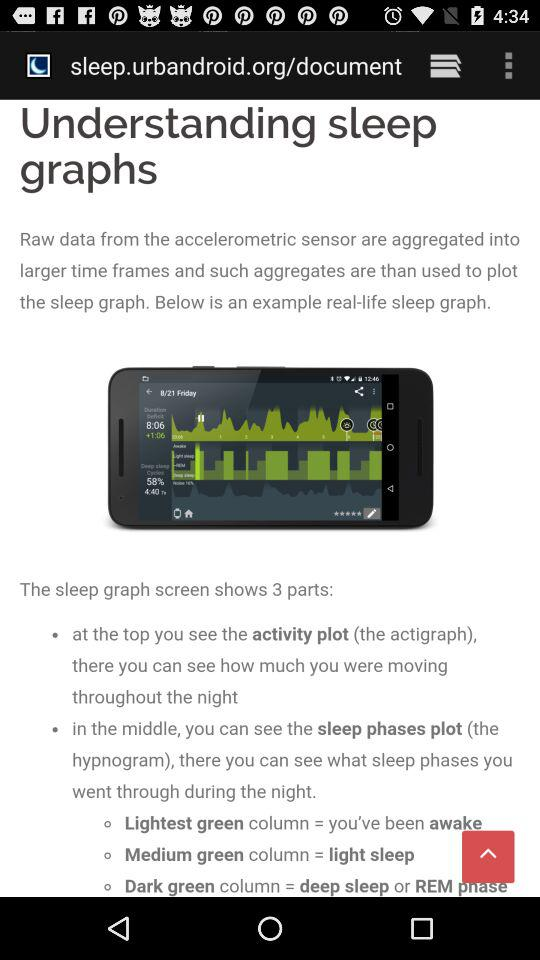What does the dark green column in the sleep graph represent? The dark green column in the sleep graph represents deep sleep or the REM phase. 